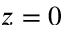<formula> <loc_0><loc_0><loc_500><loc_500>z = 0</formula> 